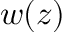<formula> <loc_0><loc_0><loc_500><loc_500>w ( z )</formula> 